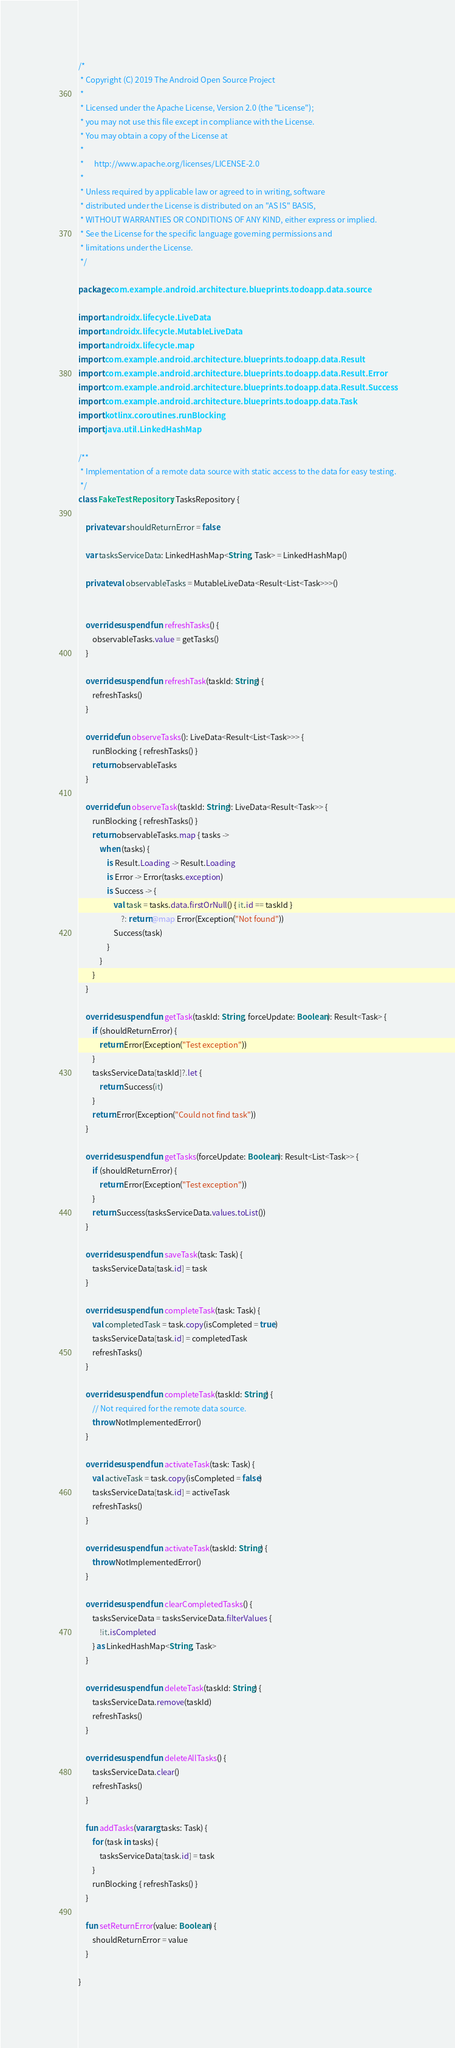<code> <loc_0><loc_0><loc_500><loc_500><_Kotlin_>/*
 * Copyright (C) 2019 The Android Open Source Project
 *
 * Licensed under the Apache License, Version 2.0 (the "License");
 * you may not use this file except in compliance with the License.
 * You may obtain a copy of the License at
 *
 *      http://www.apache.org/licenses/LICENSE-2.0
 *
 * Unless required by applicable law or agreed to in writing, software
 * distributed under the License is distributed on an "AS IS" BASIS,
 * WITHOUT WARRANTIES OR CONDITIONS OF ANY KIND, either express or implied.
 * See the License for the specific language governing permissions and
 * limitations under the License.
 */

package com.example.android.architecture.blueprints.todoapp.data.source

import androidx.lifecycle.LiveData
import androidx.lifecycle.MutableLiveData
import androidx.lifecycle.map
import com.example.android.architecture.blueprints.todoapp.data.Result
import com.example.android.architecture.blueprints.todoapp.data.Result.Error
import com.example.android.architecture.blueprints.todoapp.data.Result.Success
import com.example.android.architecture.blueprints.todoapp.data.Task
import kotlinx.coroutines.runBlocking
import java.util.LinkedHashMap

/**
 * Implementation of a remote data source with static access to the data for easy testing.
 */
class FakeTestRepository : TasksRepository {

    private var shouldReturnError = false

    var tasksServiceData: LinkedHashMap<String, Task> = LinkedHashMap()

    private val observableTasks = MutableLiveData<Result<List<Task>>>()


    override suspend fun refreshTasks() {
        observableTasks.value = getTasks()
    }

    override suspend fun refreshTask(taskId: String) {
        refreshTasks()
    }

    override fun observeTasks(): LiveData<Result<List<Task>>> {
        runBlocking { refreshTasks() }
        return observableTasks
    }

    override fun observeTask(taskId: String): LiveData<Result<Task>> {
        runBlocking { refreshTasks() }
        return observableTasks.map { tasks ->
            when (tasks) {
                is Result.Loading -> Result.Loading
                is Error -> Error(tasks.exception)
                is Success -> {
                    val task = tasks.data.firstOrNull() { it.id == taskId }
                        ?: return@map Error(Exception("Not found"))
                    Success(task)
                }
            }
        }
    }

    override suspend fun getTask(taskId: String, forceUpdate: Boolean): Result<Task> {
        if (shouldReturnError) {
            return Error(Exception("Test exception"))
        }
        tasksServiceData[taskId]?.let {
            return Success(it)
        }
        return Error(Exception("Could not find task"))
    }

    override suspend fun getTasks(forceUpdate: Boolean): Result<List<Task>> {
        if (shouldReturnError) {
            return Error(Exception("Test exception"))
        }
        return Success(tasksServiceData.values.toList())
    }

    override suspend fun saveTask(task: Task) {
        tasksServiceData[task.id] = task
    }

    override suspend fun completeTask(task: Task) {
        val completedTask = task.copy(isCompleted = true)
        tasksServiceData[task.id] = completedTask
        refreshTasks()
    }

    override suspend fun completeTask(taskId: String) {
        // Not required for the remote data source.
        throw NotImplementedError()
    }

    override suspend fun activateTask(task: Task) {
        val activeTask = task.copy(isCompleted = false)
        tasksServiceData[task.id] = activeTask
        refreshTasks()
    }

    override suspend fun activateTask(taskId: String) {
        throw NotImplementedError()
    }

    override suspend fun clearCompletedTasks() {
        tasksServiceData = tasksServiceData.filterValues {
            !it.isCompleted
        } as LinkedHashMap<String, Task>
    }

    override suspend fun deleteTask(taskId: String) {
        tasksServiceData.remove(taskId)
        refreshTasks()
    }

    override suspend fun deleteAllTasks() {
        tasksServiceData.clear()
        refreshTasks()
    }

    fun addTasks(vararg tasks: Task) {
        for (task in tasks) {
            tasksServiceData[task.id] = task
        }
        runBlocking { refreshTasks() }
    }

    fun setReturnError(value: Boolean) {
        shouldReturnError = value
    }

}</code> 